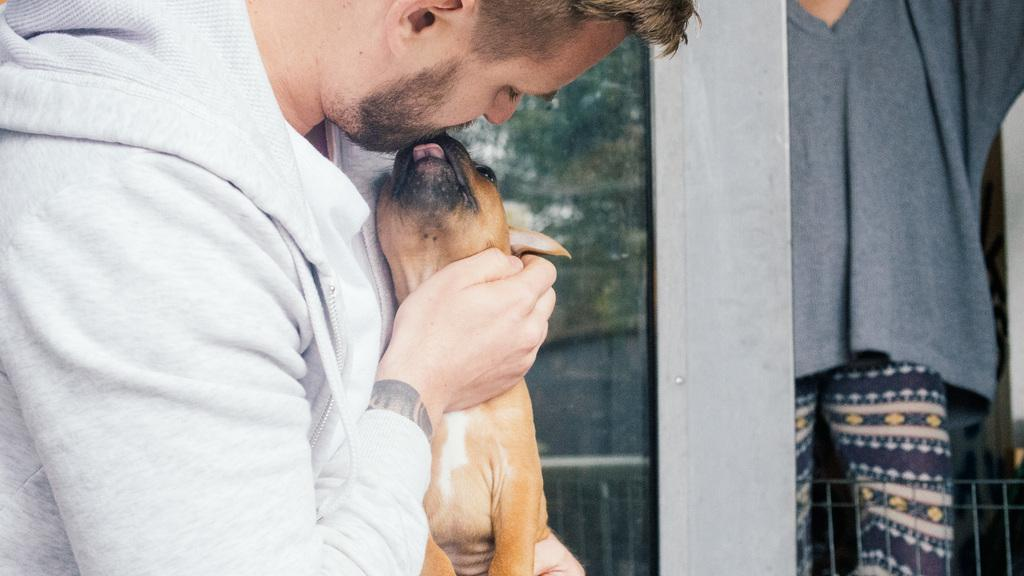What is located on the left side of the image? There is a man on the left side of the image. What is the man wearing? The man is wearing a white jacket. What is the man holding in the image? The man is holding a dog. What can be seen on the right side of the image? There is a person on the right side of the image. What type of snake can be seen slithering on the ground in the image? There is no snake present in the image; it features a man holding a dog. What color is the copper baseball bat in the image? There is no copper baseball bat present in the image. 